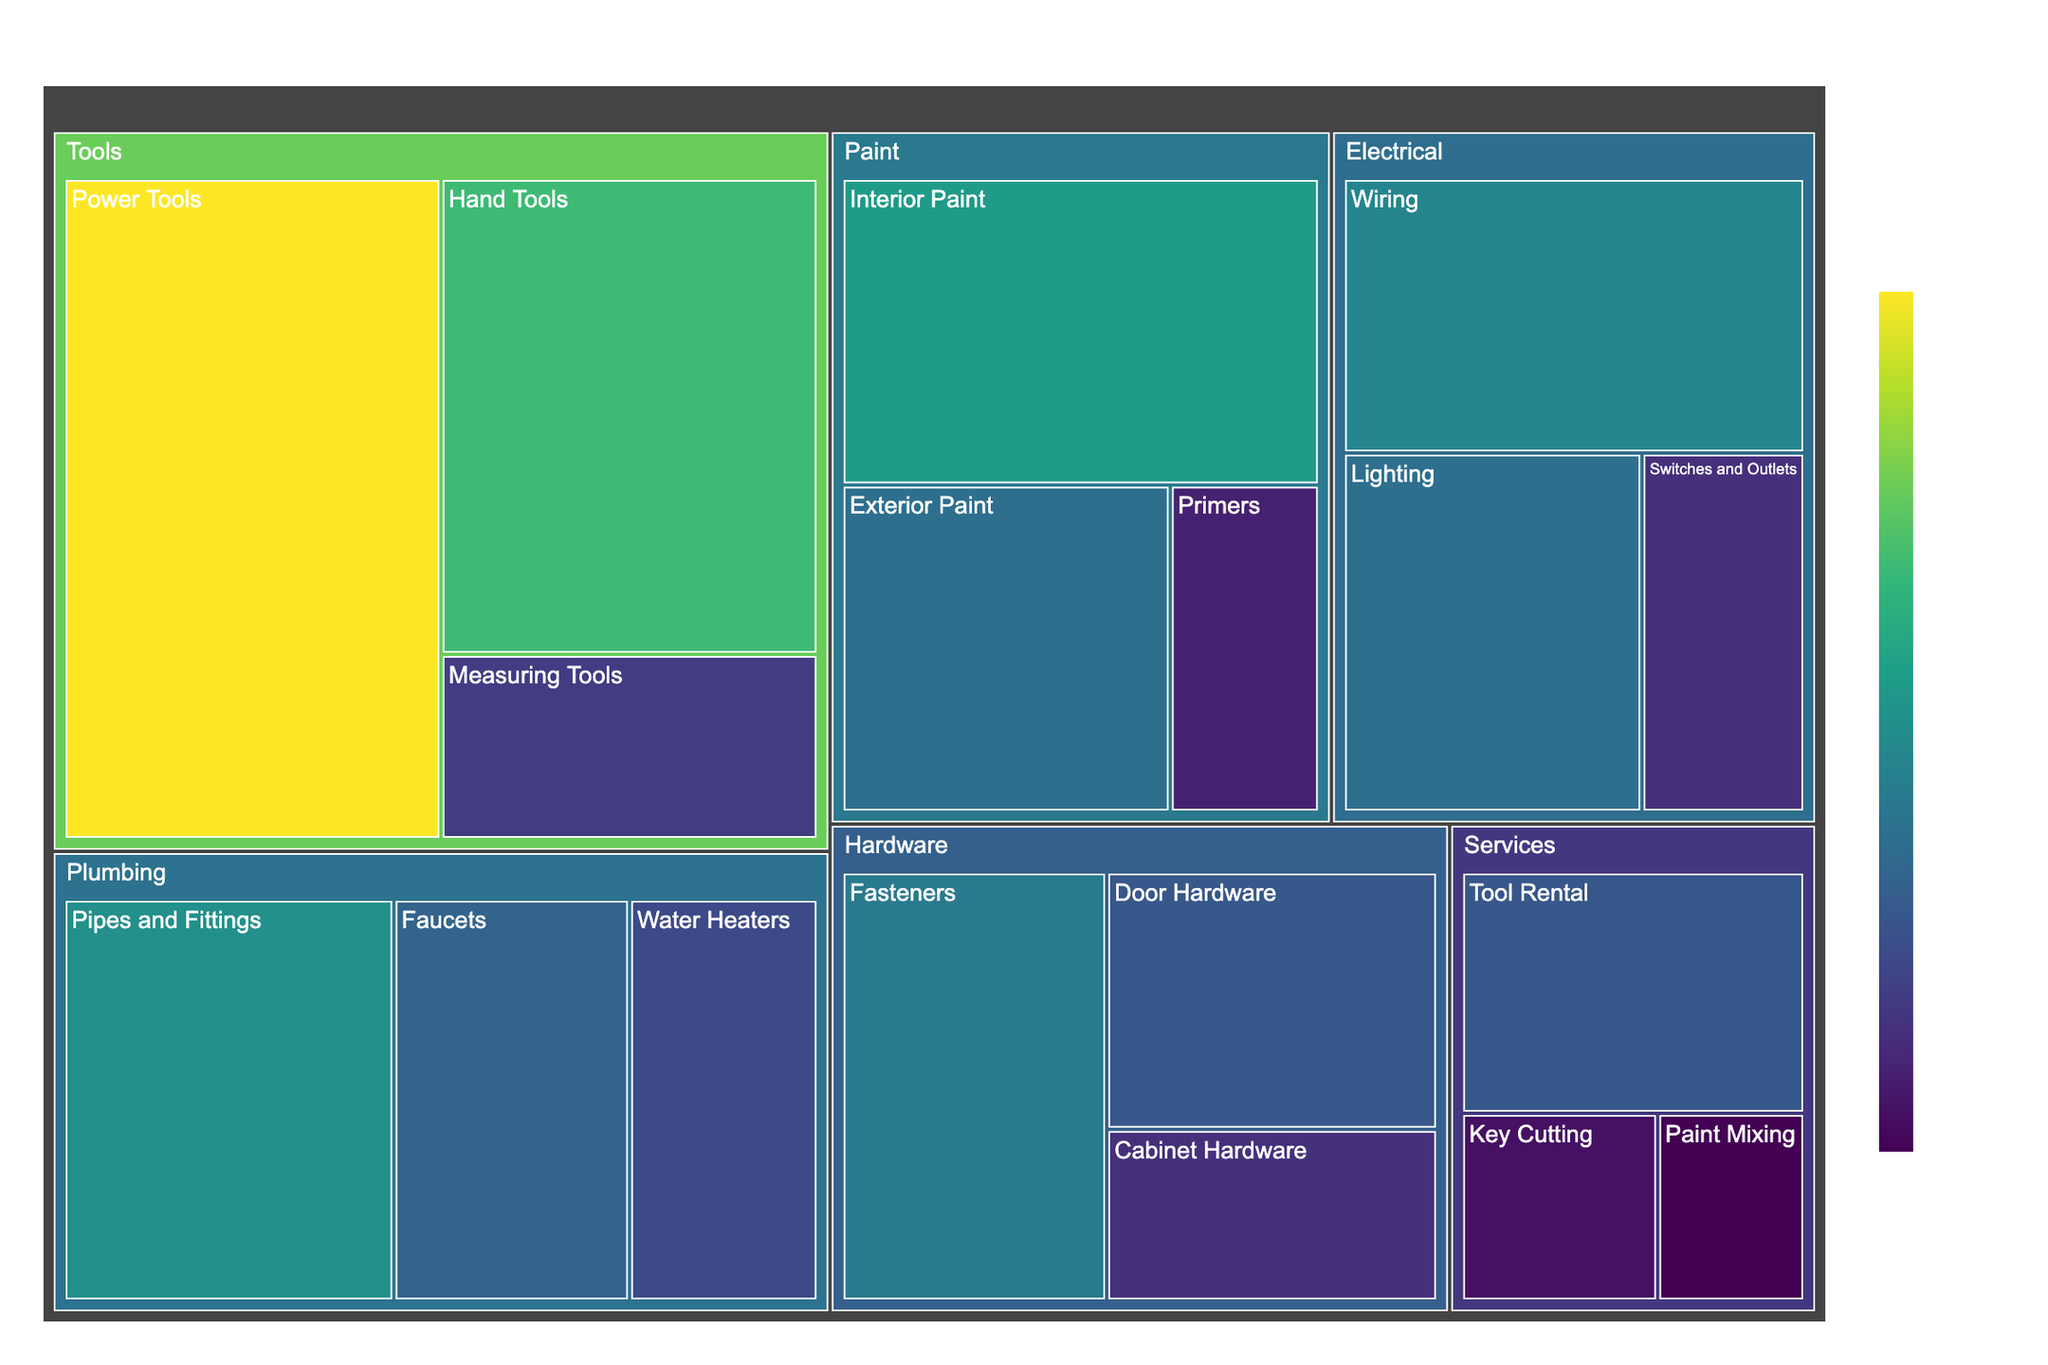What is the total revenue generated by Paint products? To find the total revenue generated by Paint products, sum the values for all Paint subcategories. This includes Interior Paint ($15,000), Exterior Paint ($11,000), and Primers ($5,000). The total revenue is $15,000 + $11,000 + $5,000 = $31,000.
Answer: $31,000 Which subcategory has the highest revenue? The subcategory with the highest revenue can be identified by looking for the largest value represented visually. Power Tools under the Tools category has the highest revenue at $25,000.
Answer: Power Tools What is the difference in revenue between Electrical and Plumbing categories? Summing up the subcategory revenues within Electrical gives $13,000 (Wiring) + $11,000 (Lighting) + $6,000 (Switches and Outlets) = $30,000. For Plumbing, it is $14,000 (Pipes and Fittings) + $10,000 (Faucets) + $8,000 (Water Heaters) = $32,000. The difference is $32,000 - $30,000 = $2,000.
Answer: $2,000 Which service generates the least revenue? By comparing all subcategories under Services, Paint Mixing has the lowest revenue at $3,000.
Answer: Paint Mixing What percentage of the total revenue does the Hardware category contribute? First, calculate the total revenue across all categories: $25,000 + $18,000 + $7,000 (Tools) + $12,000 + $9,000 + $6,000 (Hardware) + $15,000 + $11,000 + $5,000 (Paint) + $14,000 + $10,000 + $8,000 (Plumbing) + $13,000 + $11,000 + $6,000 (Electrical) + $9,000 + $4,000 + $3,000 (Services) = $206,000. Next, sum Hardware's total revenue: $12,000 + $9,000 + $6,000 = $27,000. The percentage is ($27,000 / $206,000) * 100 ≈ 13.11%.
Answer: ≈ 13.11% Are Power Tools more profitable than the entire Services category? Power Tools revenue is $25,000. Summing up all Services revenues: $9,000 + $4,000 + $3,000 = $16,000. Since $25,000 > $16,000, Power Tools are more profitable.
Answer: Yes What is the average revenue of the subcategories within the Tools category? Tools has three subcategories with revenues of $25,000, $18,000, and $7,000. The average is calculated as ($25,000 + $18,000 + $7,000) / 3 = $50,000 / 3 ≈ $16,667.
Answer: ≈ $16,667 Which category has the closest total revenue to the Electrical category? Electrical's total revenue is $13,000 + $11,000 + $6,000 = $30,000. Summing up other categories: Tools ($50,000), Hardware ($27,000), Paint ($31,000), Plumbing ($32,000), Services ($16,000). Paint is closest with $31,000.
Answer: Paint 